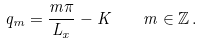Convert formula to latex. <formula><loc_0><loc_0><loc_500><loc_500>q _ { m } = \frac { m \pi } { L _ { x } } - K \quad m \in \mathbb { Z } \, .</formula> 